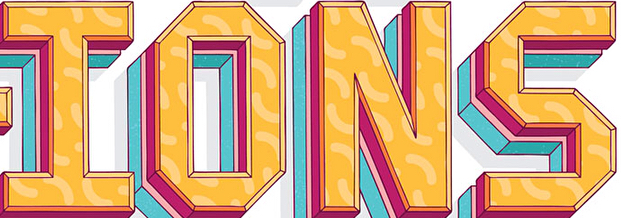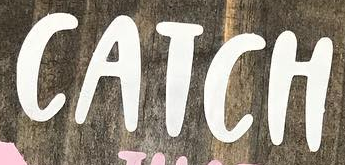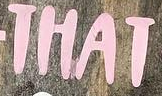What text appears in these images from left to right, separated by a semicolon? IONS; CATCH; THAT 